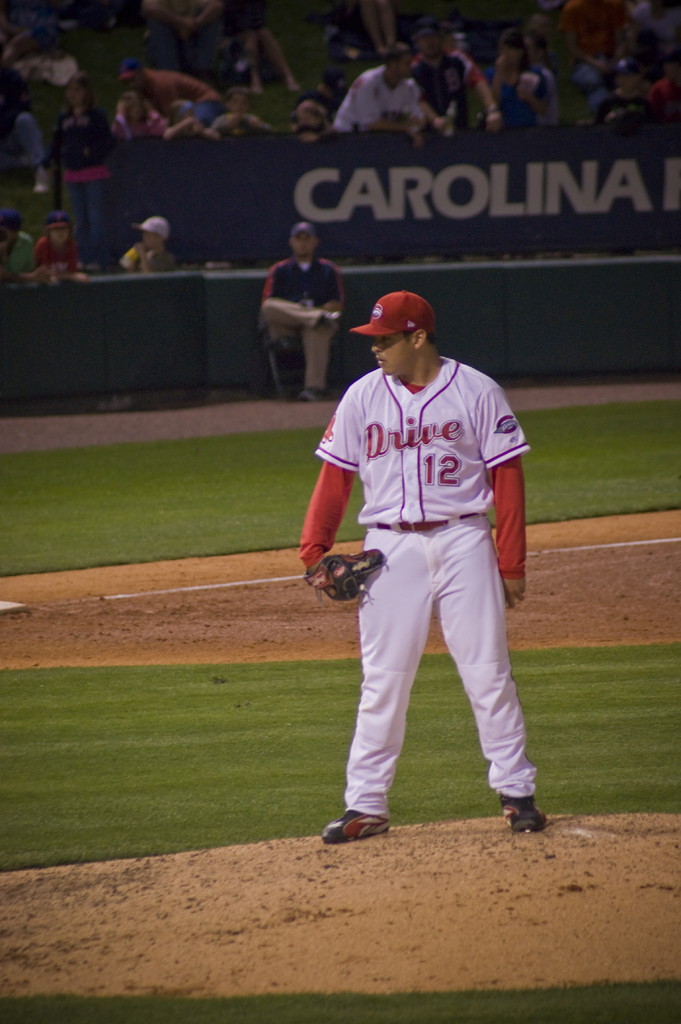Provide a one-sentence caption for the provided image. A focused baseball player in a striking red and white Drive uniform, number 12, stands on the mound at night, preparing to pitch, highlighted against the softly lit backdrop of the stadium. 